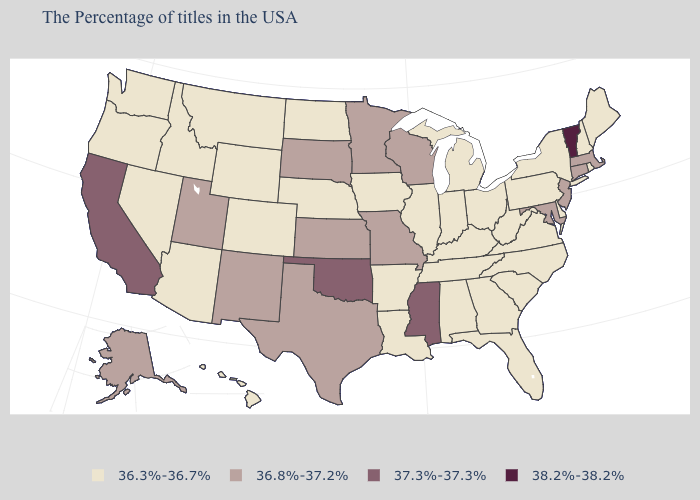What is the value of Oregon?
Concise answer only. 36.3%-36.7%. Name the states that have a value in the range 36.8%-37.2%?
Answer briefly. Massachusetts, Connecticut, New Jersey, Maryland, Wisconsin, Missouri, Minnesota, Kansas, Texas, South Dakota, New Mexico, Utah, Alaska. What is the lowest value in the USA?
Short answer required. 36.3%-36.7%. Which states have the lowest value in the MidWest?
Answer briefly. Ohio, Michigan, Indiana, Illinois, Iowa, Nebraska, North Dakota. What is the highest value in the West ?
Keep it brief. 37.3%-37.3%. What is the value of Pennsylvania?
Concise answer only. 36.3%-36.7%. Name the states that have a value in the range 38.2%-38.2%?
Be succinct. Vermont. Which states have the highest value in the USA?
Be succinct. Vermont. Name the states that have a value in the range 36.8%-37.2%?
Be succinct. Massachusetts, Connecticut, New Jersey, Maryland, Wisconsin, Missouri, Minnesota, Kansas, Texas, South Dakota, New Mexico, Utah, Alaska. Does Arkansas have the same value as Idaho?
Be succinct. Yes. Name the states that have a value in the range 36.3%-36.7%?
Short answer required. Maine, Rhode Island, New Hampshire, New York, Delaware, Pennsylvania, Virginia, North Carolina, South Carolina, West Virginia, Ohio, Florida, Georgia, Michigan, Kentucky, Indiana, Alabama, Tennessee, Illinois, Louisiana, Arkansas, Iowa, Nebraska, North Dakota, Wyoming, Colorado, Montana, Arizona, Idaho, Nevada, Washington, Oregon, Hawaii. Does Vermont have the same value as Kentucky?
Concise answer only. No. Among the states that border Oregon , which have the lowest value?
Write a very short answer. Idaho, Nevada, Washington. Which states hav the highest value in the South?
Quick response, please. Mississippi, Oklahoma. 